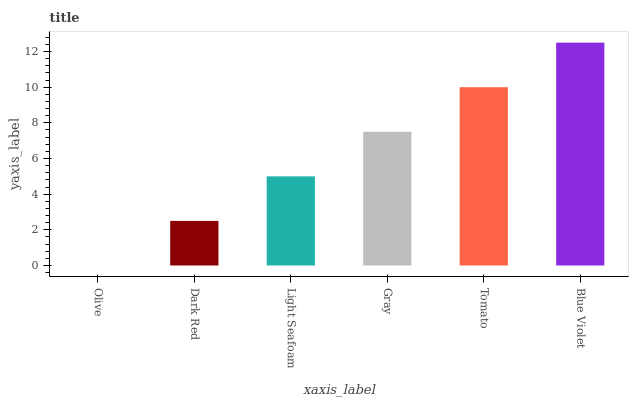Is Olive the minimum?
Answer yes or no. Yes. Is Blue Violet the maximum?
Answer yes or no. Yes. Is Dark Red the minimum?
Answer yes or no. No. Is Dark Red the maximum?
Answer yes or no. No. Is Dark Red greater than Olive?
Answer yes or no. Yes. Is Olive less than Dark Red?
Answer yes or no. Yes. Is Olive greater than Dark Red?
Answer yes or no. No. Is Dark Red less than Olive?
Answer yes or no. No. Is Gray the high median?
Answer yes or no. Yes. Is Light Seafoam the low median?
Answer yes or no. Yes. Is Blue Violet the high median?
Answer yes or no. No. Is Tomato the low median?
Answer yes or no. No. 